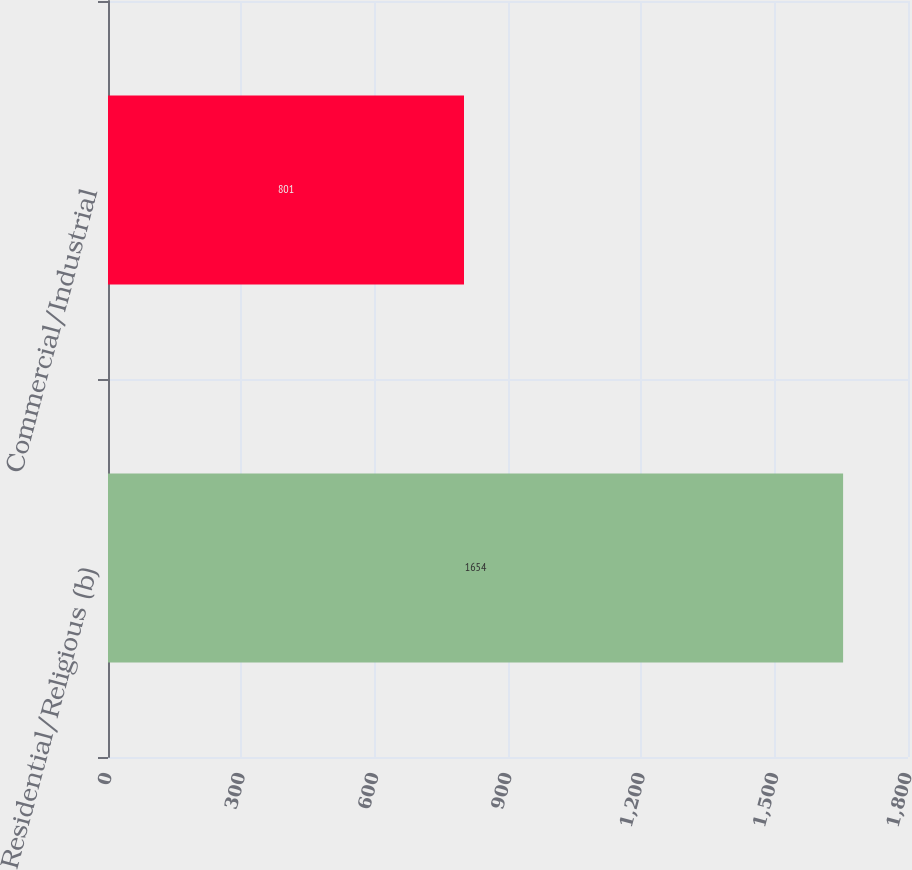Convert chart to OTSL. <chart><loc_0><loc_0><loc_500><loc_500><bar_chart><fcel>Residential/Religious (b)<fcel>Commercial/Industrial<nl><fcel>1654<fcel>801<nl></chart> 